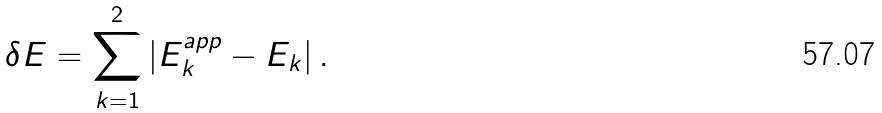Convert formula to latex. <formula><loc_0><loc_0><loc_500><loc_500>\delta E = \sum _ { k = 1 } ^ { 2 } | E ^ { a p p } _ { k } - E _ { k } | \, .</formula> 